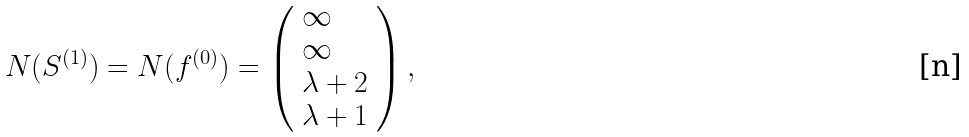Convert formula to latex. <formula><loc_0><loc_0><loc_500><loc_500>N ( S ^ { ( 1 ) } ) = N ( f ^ { ( 0 ) } ) = \left ( \begin{array} { l } \infty \\ \infty \\ \lambda + 2 \\ \lambda + 1 \end{array} \right ) ,</formula> 